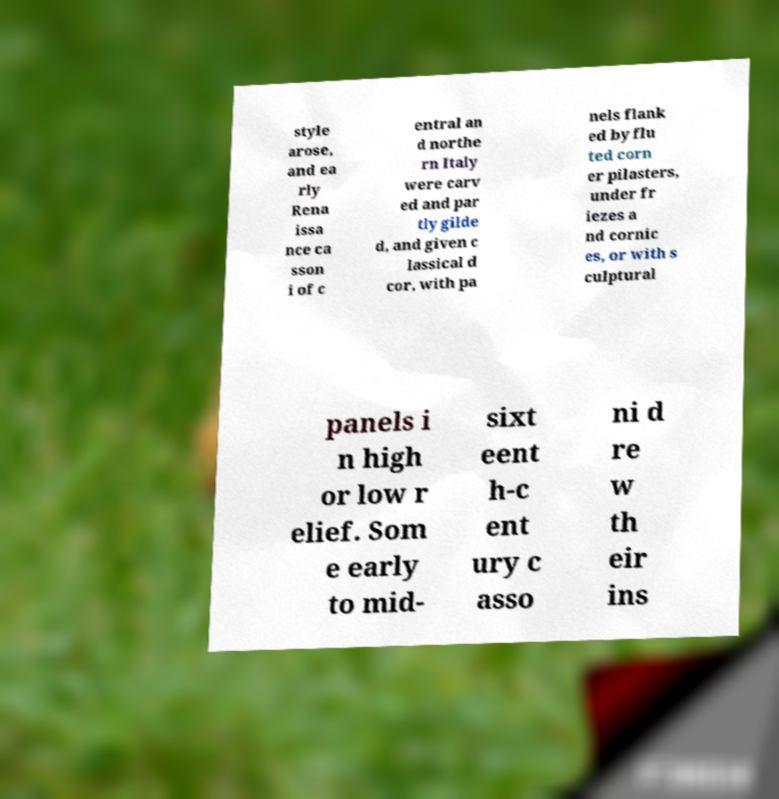Please identify and transcribe the text found in this image. style arose, and ea rly Rena issa nce ca sson i of c entral an d northe rn Italy were carv ed and par tly gilde d, and given c lassical d cor, with pa nels flank ed by flu ted corn er pilasters, under fr iezes a nd cornic es, or with s culptural panels i n high or low r elief. Som e early to mid- sixt eent h-c ent ury c asso ni d re w th eir ins 